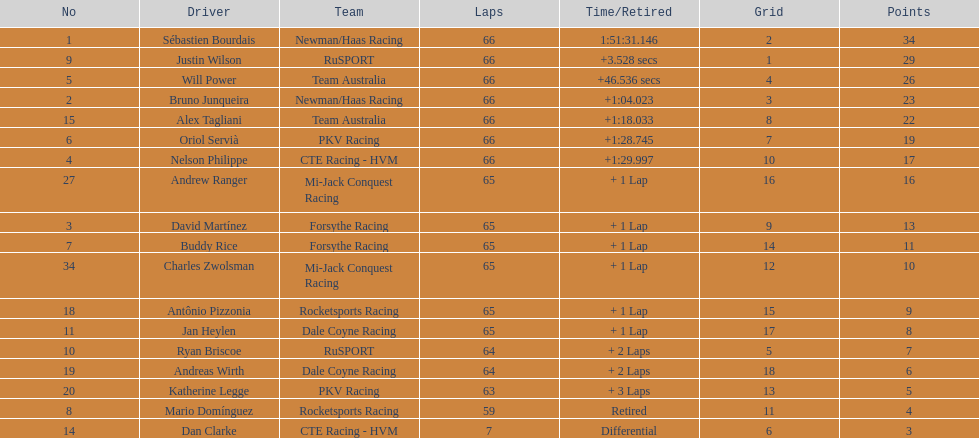Would you mind parsing the complete table? {'header': ['No', 'Driver', 'Team', 'Laps', 'Time/Retired', 'Grid', 'Points'], 'rows': [['1', 'Sébastien Bourdais', 'Newman/Haas Racing', '66', '1:51:31.146', '2', '34'], ['9', 'Justin Wilson', 'RuSPORT', '66', '+3.528 secs', '1', '29'], ['5', 'Will Power', 'Team Australia', '66', '+46.536 secs', '4', '26'], ['2', 'Bruno Junqueira', 'Newman/Haas Racing', '66', '+1:04.023', '3', '23'], ['15', 'Alex Tagliani', 'Team Australia', '66', '+1:18.033', '8', '22'], ['6', 'Oriol Servià', 'PKV Racing', '66', '+1:28.745', '7', '19'], ['4', 'Nelson Philippe', 'CTE Racing - HVM', '66', '+1:29.997', '10', '17'], ['27', 'Andrew Ranger', 'Mi-Jack Conquest Racing', '65', '+ 1 Lap', '16', '16'], ['3', 'David Martínez', 'Forsythe Racing', '65', '+ 1 Lap', '9', '13'], ['7', 'Buddy Rice', 'Forsythe Racing', '65', '+ 1 Lap', '14', '11'], ['34', 'Charles Zwolsman', 'Mi-Jack Conquest Racing', '65', '+ 1 Lap', '12', '10'], ['18', 'Antônio Pizzonia', 'Rocketsports Racing', '65', '+ 1 Lap', '15', '9'], ['11', 'Jan Heylen', 'Dale Coyne Racing', '65', '+ 1 Lap', '17', '8'], ['10', 'Ryan Briscoe', 'RuSPORT', '64', '+ 2 Laps', '5', '7'], ['19', 'Andreas Wirth', 'Dale Coyne Racing', '64', '+ 2 Laps', '18', '6'], ['20', 'Katherine Legge', 'PKV Racing', '63', '+ 3 Laps', '13', '5'], ['8', 'Mario Domínguez', 'Rocketsports Racing', '59', 'Retired', '11', '4'], ['14', 'Dan Clarke', 'CTE Racing - HVM', '7', 'Differential', '6', '3']]} At the 2006 gran premio telmex, who scored the highest number of points? Sébastien Bourdais. 